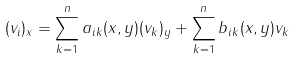<formula> <loc_0><loc_0><loc_500><loc_500>( v _ { i } ) _ { x } = \sum _ { k = 1 } ^ { n } a _ { i k } ( x , y ) ( v _ { k } ) _ { y } + \sum _ { k = 1 } ^ { n } b _ { i k } ( x , y ) v _ { k }</formula> 